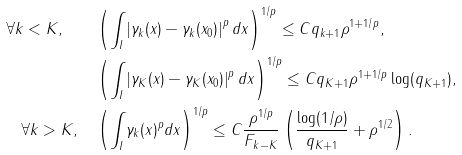<formula> <loc_0><loc_0><loc_500><loc_500>\forall k < K , \quad & \left ( \int _ { I } \left | \gamma _ { k } ( x ) - \gamma _ { k } ( x _ { 0 } ) \right | ^ { p } d x \right ) ^ { 1 / p } \leq C q _ { k + 1 } \rho ^ { 1 + 1 / p } , \\ & \left ( \int _ { I } \left | \gamma _ { K } ( x ) - \gamma _ { K } ( x _ { 0 } ) \right | ^ { p } d x \right ) ^ { 1 / p } \leq C q _ { K + 1 } \rho ^ { 1 + 1 / p } \log ( q _ { K + 1 } ) , \\ \forall k > K , \quad & \left ( \int _ { I } \gamma _ { k } ( x ) ^ { p } d x \right ) ^ { 1 / p } \leq C \frac { \rho ^ { 1 / p } } { F _ { k - K } } \left ( \frac { \log ( 1 / \rho ) } { q _ { K + 1 } } + \rho ^ { 1 / 2 } \right ) .</formula> 